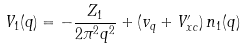Convert formula to latex. <formula><loc_0><loc_0><loc_500><loc_500>V _ { 1 } ( q ) = - \frac { Z _ { 1 } } { 2 \pi ^ { 2 } q ^ { 2 } } + ( v _ { q } + V ^ { \prime } _ { x c } ) \, n _ { 1 } ( q )</formula> 